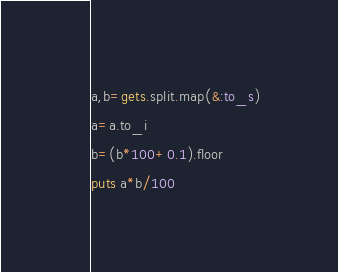<code> <loc_0><loc_0><loc_500><loc_500><_Ruby_>a,b=gets.split.map(&:to_s)
a=a.to_i
b=(b*100+0.1).floor
puts a*b/100
</code> 